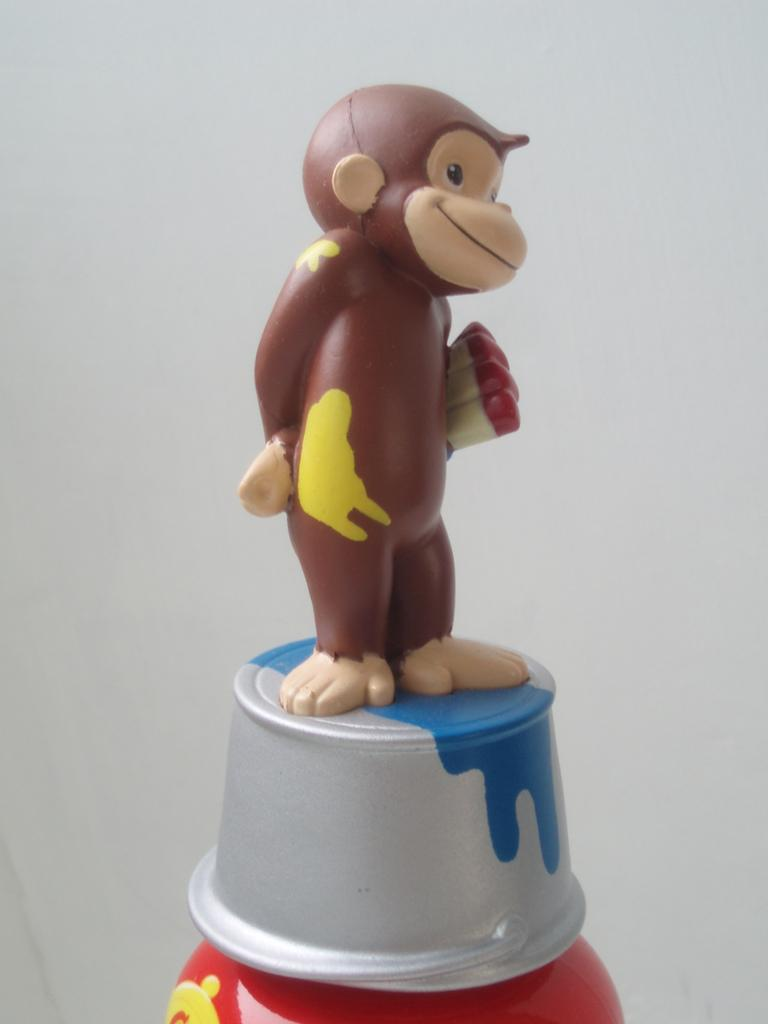What can be seen in the image that is likely to be used for play or entertainment? There is a toy in the image. What is the toy resting on or attached to? The toy is on some object. What can be seen in the distance behind the toy? There is a wall in the background of the image. How steep is the slope in the image? There is no slope present in the image. How many family members can be seen in the image? There is no family present in the image. 